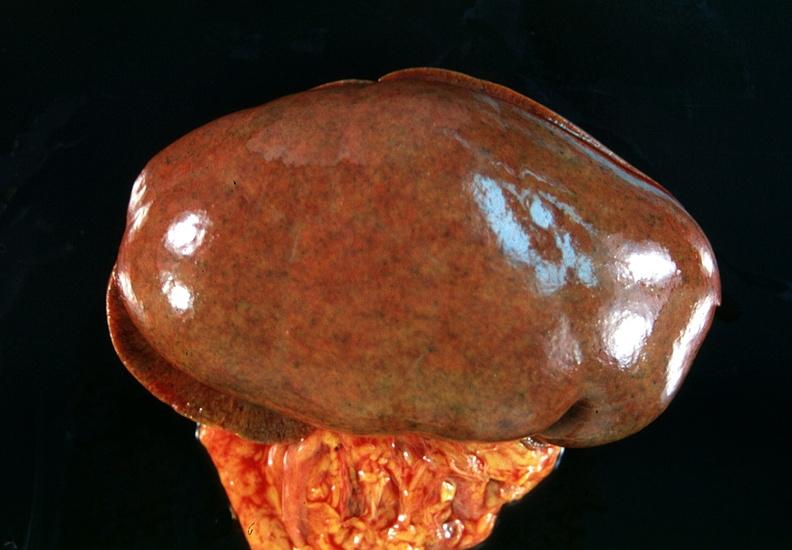where is this?
Answer the question using a single word or phrase. Urinary 